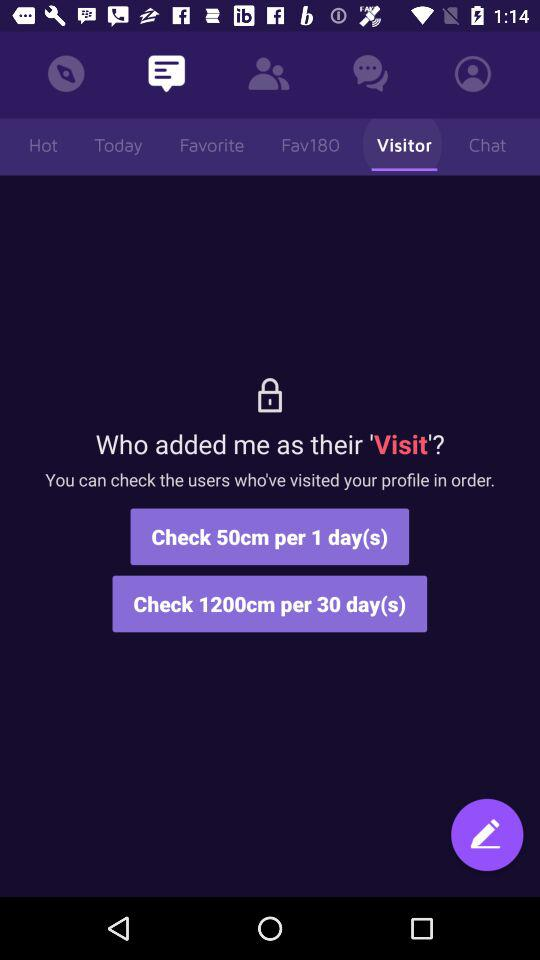Which option is selected from the title bar? The selected option from the title bar is "Visitor". 